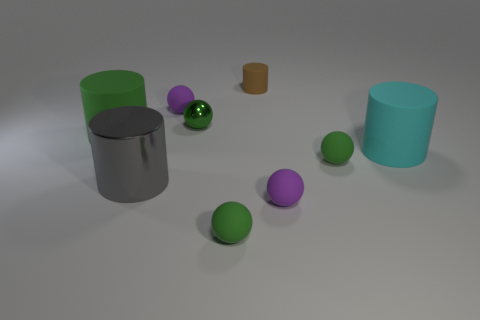How many blocks are either rubber objects or large brown rubber objects?
Your response must be concise. 0. Is the number of cyan matte things greater than the number of small objects?
Make the answer very short. No. How many metal spheres are the same size as the gray metallic object?
Your answer should be very brief. 0. There is a big matte thing that is the same color as the small shiny ball; what is its shape?
Provide a short and direct response. Cylinder. What number of objects are big objects on the right side of the brown rubber thing or green rubber things?
Your answer should be very brief. 4. Is the number of big things less than the number of large green matte things?
Provide a short and direct response. No. There is another tiny object that is made of the same material as the gray object; what shape is it?
Offer a terse response. Sphere. Are there any shiny balls right of the cyan rubber thing?
Offer a terse response. No. Is the number of green metal things left of the large gray thing less than the number of cylinders?
Give a very brief answer. Yes. What is the material of the gray cylinder?
Keep it short and to the point. Metal. 